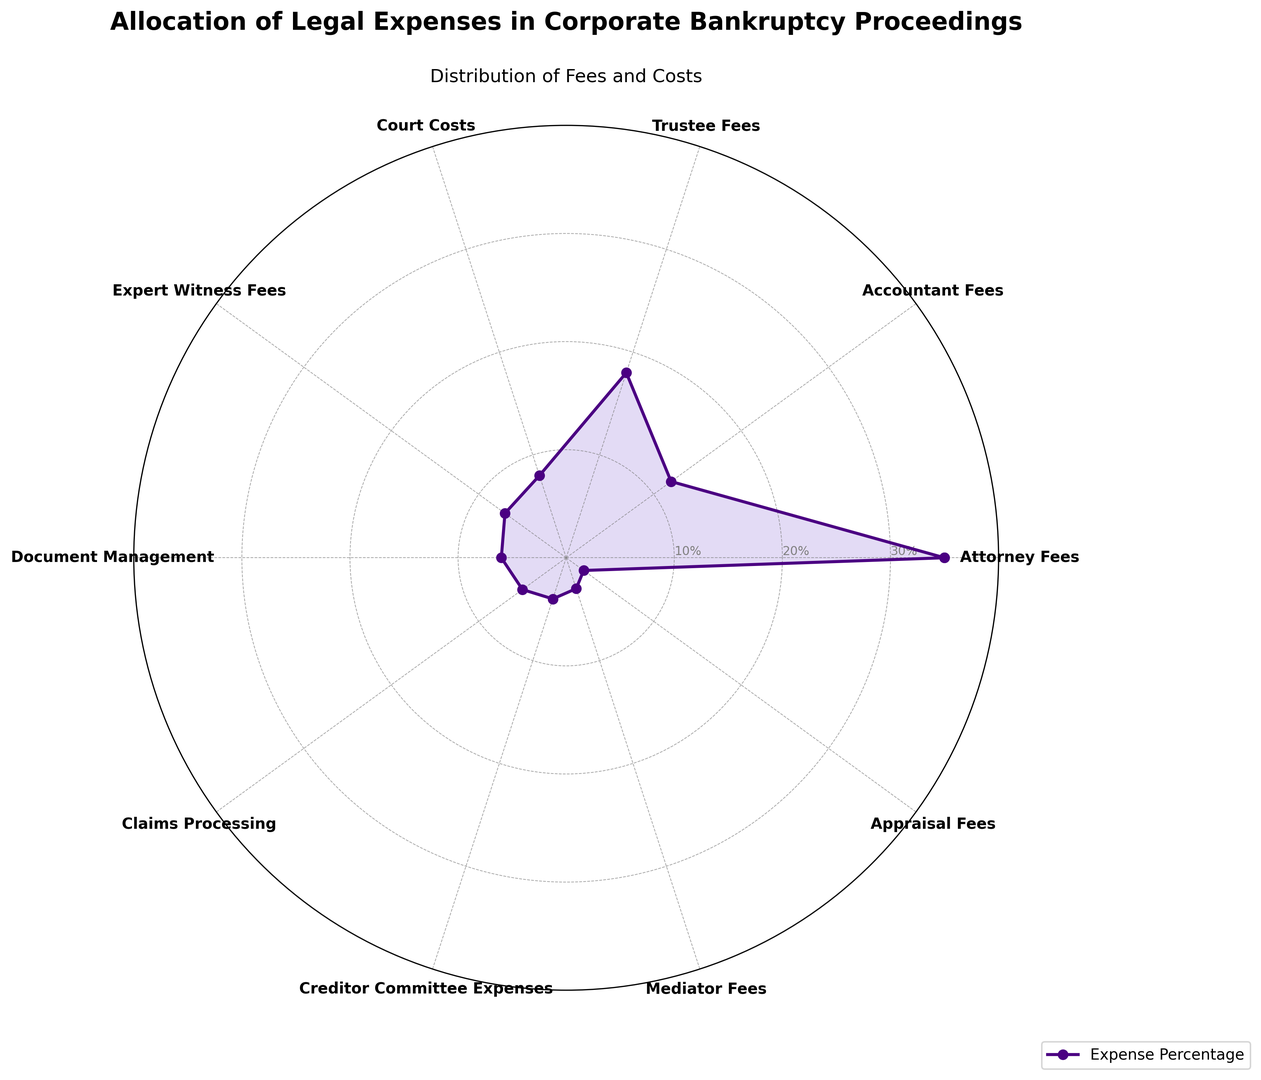Which category has the highest percentage allocation in the chart? From the plot, the category that exhibits the highest radial extent (about 35%) is "Attorney Fees".
Answer: Attorney Fees What is the combined percentage of Accountant Fees and Trustee Fees? From the figure, Accountant Fees is 12% and Trustee Fees is 18%. Adding these together yields 12% + 18% = 30%.
Answer: 30% How does the percentage allocation of Court Costs compare to that of Document Management? Referring to the chart, Court Costs are at 8%, whereas Document Management is at 6%. Comparatively, Court Costs are higher by 2%.
Answer: Court Costs are higher by 2% Which categories have a percentage allocation less than or equal to 5%? According to the figure, the categories with 5% or less are Claims Processing (5%), Creditor Committee Expenses (4%), Mediator Fees (3%), and Appraisal Fees (2%).
Answer: Claims Processing, Creditor Committee Expenses, Mediator Fees, Appraisal Fees What’s the total percentage allocated to Expert Witness Fees, Document Management, and Claims Processing combined? From the plot, Expert Witness Fees is 7%, Document Management is 6%, and Claims Processing is 5%. Adding these values gives 7% + 6% + 5% = 18%.
Answer: 18% Between Attorney Fees and Attorney Expenses, which has a higher allocation, and by how much? Attorney Fees stand at 35%, and Creditor Committee Expenses are at 4%. Thus, Attorney Fees are higher by 35% - 4% = 31%.
Answer: Attorney Fees are higher by 31% Among Accountant Fees, Trustee Fees, and Court Costs, which category has the lowest allocation? From the chart, Accountant Fees and Trustee Fees have allocations of 12% and 18%, respectively. Court Costs, with 8%, is the lowest among the three.
Answer: Court Costs How much more is allocated to Trustee Fees than to Mediator Fees? The plot shows Trustee Fees at 18% and Mediator Fees at 3%. Therefore, Trustee Fees are higher by 18% - 3% = 15%.
Answer: 15% What is the approximate difference in percentage between the categories with the highest and the lowest allocations? The category with the highest allocation is Attorney Fees at 35%, and the lowest is Appraisal Fees at 2%. The difference is approximately 35% - 2% = 33%.
Answer: 33% Ignoring the highest expense, what is the average percentage allocation of the remaining categories? Excluding Attorney Fees (35%), the remaining percentages are: 12%, 18%, 8%, 7%, 6%, 5%, 4%, 3%, and 2%. Summing these yields 65% and dividing by 9 (number of remaining categories) equals 65/9 ≈ 7.22%.
Answer: 7.22% 